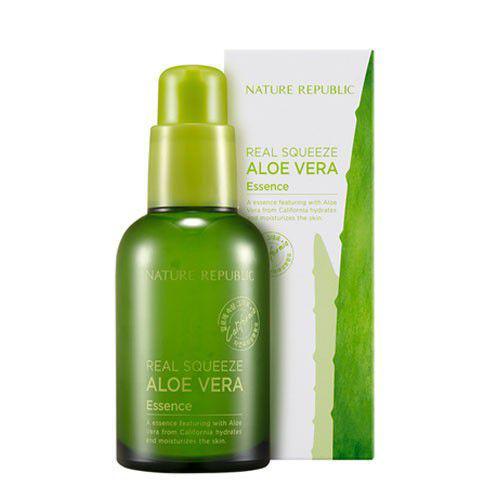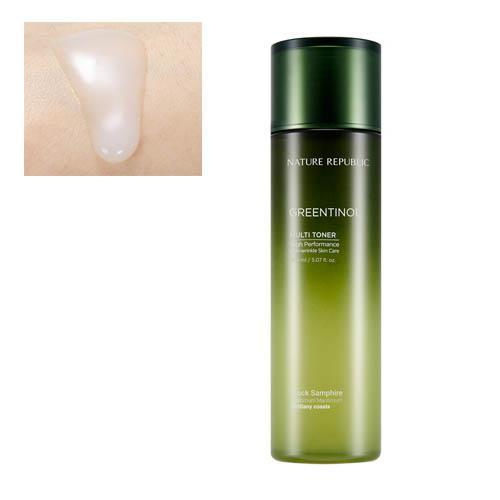The first image is the image on the left, the second image is the image on the right. For the images displayed, is the sentence "The combined images include cylindrical bottles with green tops fading down to silver, upright green rectangular boxes, and no other products." factually correct? Answer yes or no. No. The first image is the image on the left, the second image is the image on the right. Evaluate the accuracy of this statement regarding the images: "The container in one of the images has a dark colored cap.". Is it true? Answer yes or no. Yes. 